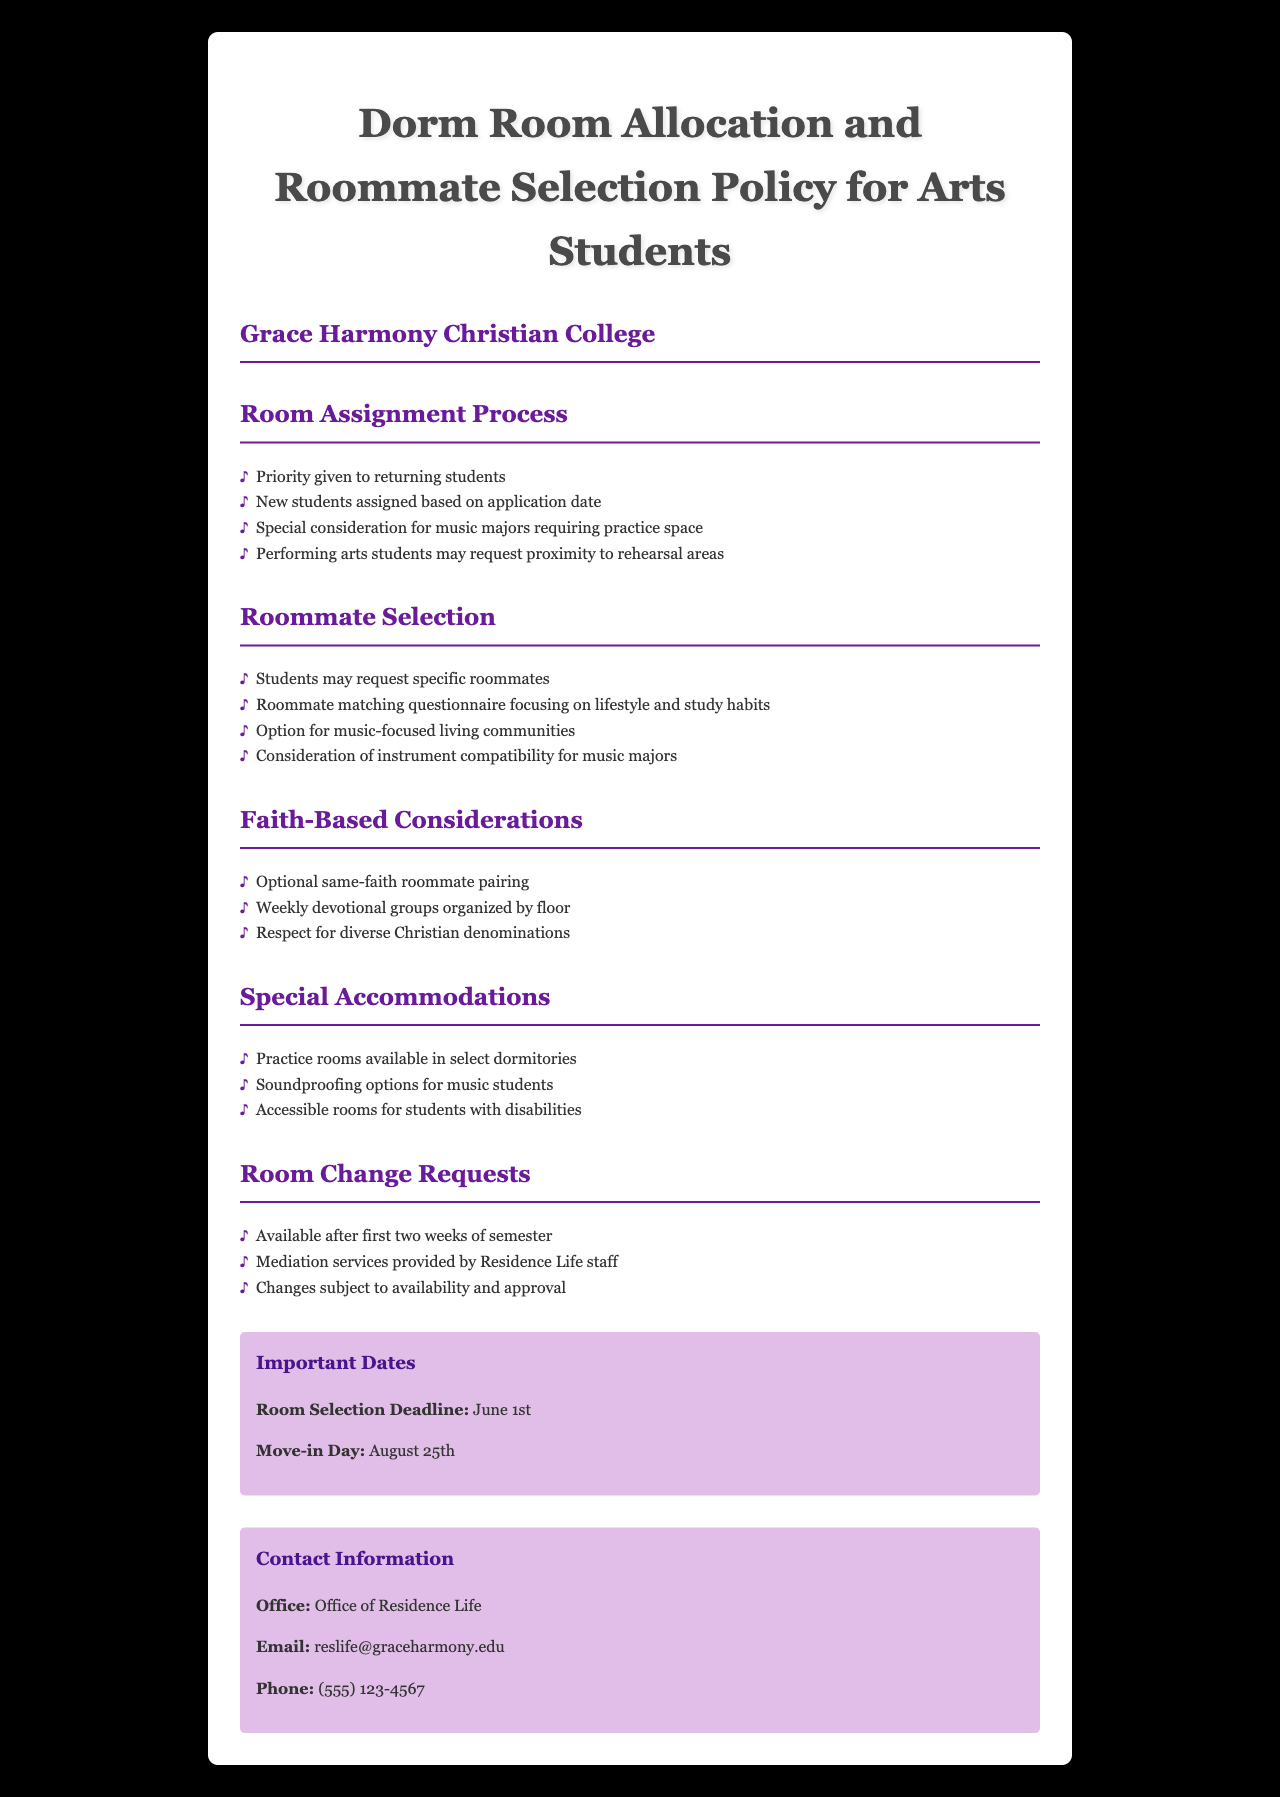What is the priority for room assignment? The priority for room assignment is given to returning students.
Answer: Returning students Who may request specific roommates? Specific roommate requests can be made by students.
Answer: Students What special consideration is given to music majors? Music majors requiring practice space receive special consideration.
Answer: Practice space When is the room selection deadline? The room selection deadline is mentioned under important dates, which is June 1st.
Answer: June 1st What is organized weekly for students? Weekly devotional groups are organized by floor.
Answer: Devotional groups When can room change requests be made? Room change requests can be made after the first two weeks of the semester.
Answer: After first two weeks What type of living communities is available? The document mentions options for music-focused living communities.
Answer: Music-focused living communities What should students consider for roommate matching? Students should focus on lifestyle and study habits in the roommate matching questionnaire.
Answer: Lifestyle and study habits What options are available for soundproofing? The document states that soundproofing options are available for music students.
Answer: Soundproofing options 